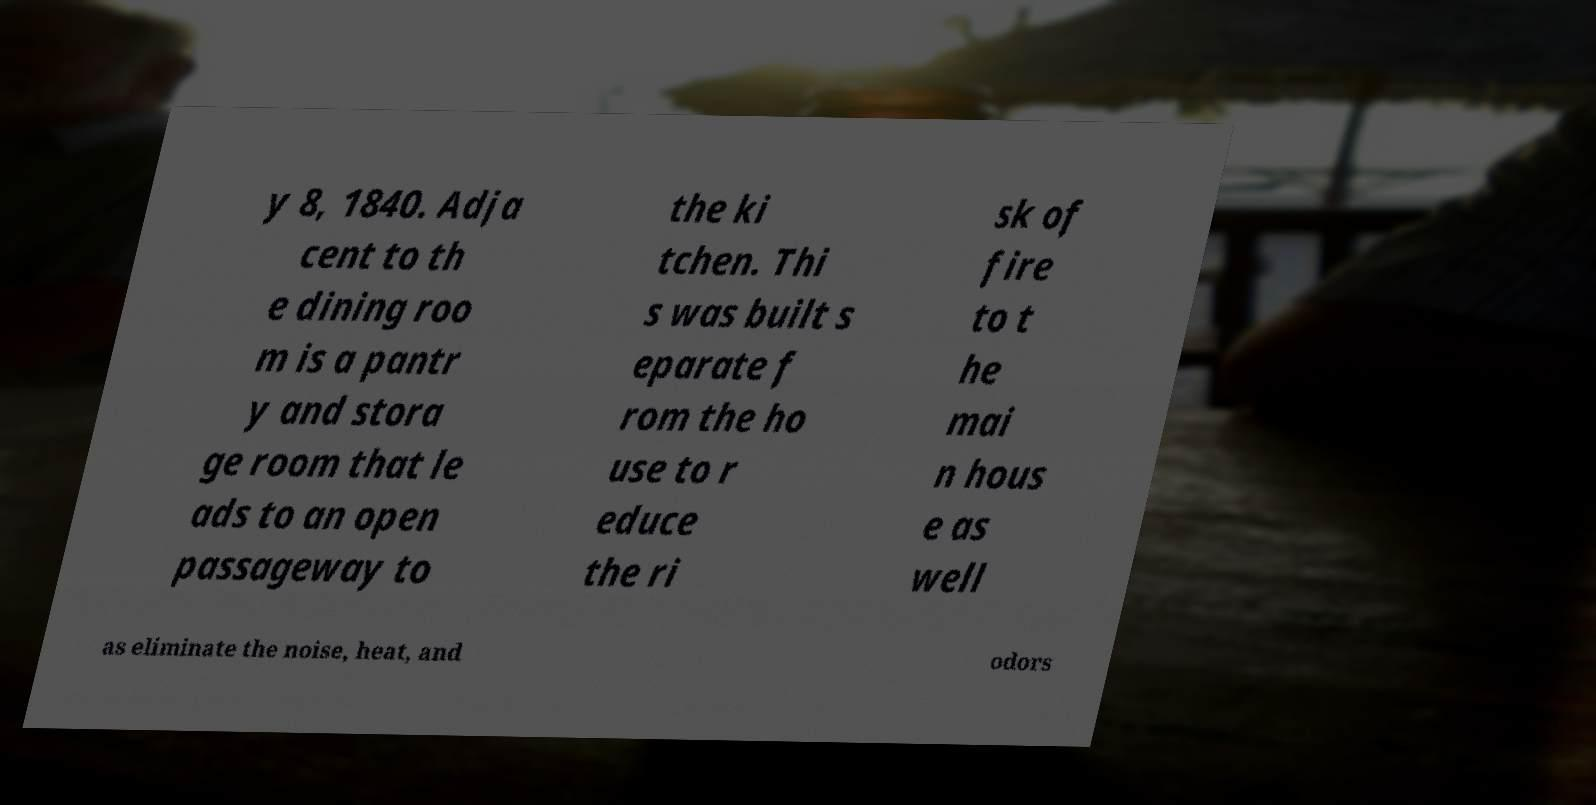Could you extract and type out the text from this image? y 8, 1840. Adja cent to th e dining roo m is a pantr y and stora ge room that le ads to an open passageway to the ki tchen. Thi s was built s eparate f rom the ho use to r educe the ri sk of fire to t he mai n hous e as well as eliminate the noise, heat, and odors 